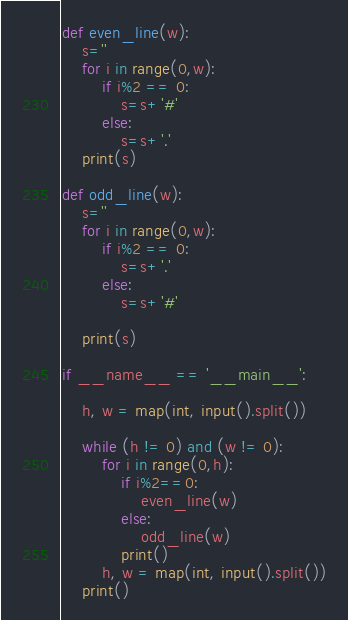<code> <loc_0><loc_0><loc_500><loc_500><_Python_>def even_line(w):
    s=''
    for i in range(0,w):
        if i%2 == 0:
            s=s+'#'
        else:
            s=s+'.'
    print(s)

def odd_line(w):
    s=''
    for i in range(0,w):
        if i%2 == 0:
            s=s+'.'
        else:
            s=s+'#'

    print(s)

if __name__ == '__main__':

    h, w = map(int, input().split())

    while (h != 0) and (w != 0):
        for i in range(0,h):
            if i%2==0:
                even_line(w)
            else:
                odd_line(w)
            print()
        h, w = map(int, input().split())
    print()

</code> 